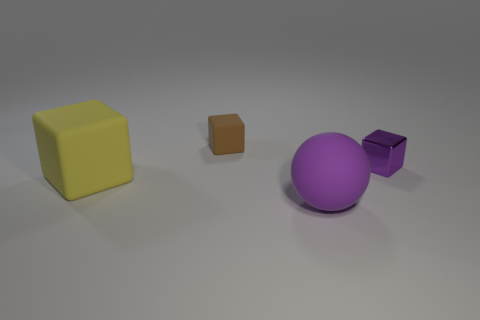Are there any other things that are made of the same material as the purple block?
Offer a very short reply. No. How many things are large rubber objects that are on the right side of the big matte block or small purple matte balls?
Provide a succinct answer. 1. Are there an equal number of big yellow rubber things that are behind the tiny metallic block and big blue rubber cylinders?
Provide a succinct answer. Yes. Is the color of the ball the same as the shiny block?
Ensure brevity in your answer.  Yes. What color is the matte thing that is both behind the big purple rubber object and in front of the small brown block?
Provide a succinct answer. Yellow. What number of cubes are either big rubber things or small brown matte things?
Your response must be concise. 2. Is the number of large balls that are behind the large purple matte sphere less than the number of tiny purple metallic blocks?
Keep it short and to the point. Yes. The big purple object that is made of the same material as the brown object is what shape?
Give a very brief answer. Sphere. What number of matte things are the same color as the tiny metallic thing?
Give a very brief answer. 1. How many objects are either tiny purple metallic objects or tiny purple spheres?
Provide a succinct answer. 1. 